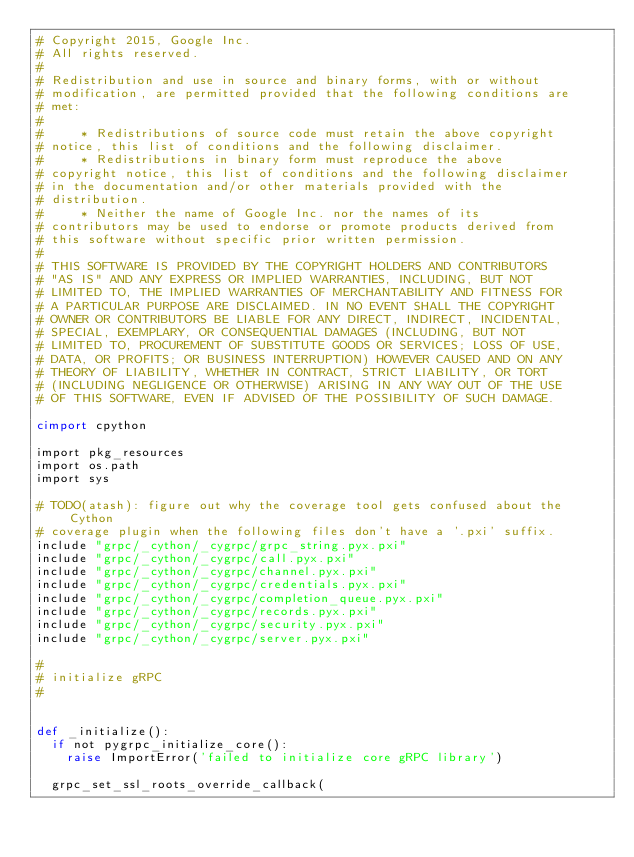Convert code to text. <code><loc_0><loc_0><loc_500><loc_500><_Cython_># Copyright 2015, Google Inc.
# All rights reserved.
#
# Redistribution and use in source and binary forms, with or without
# modification, are permitted provided that the following conditions are
# met:
#
#     * Redistributions of source code must retain the above copyright
# notice, this list of conditions and the following disclaimer.
#     * Redistributions in binary form must reproduce the above
# copyright notice, this list of conditions and the following disclaimer
# in the documentation and/or other materials provided with the
# distribution.
#     * Neither the name of Google Inc. nor the names of its
# contributors may be used to endorse or promote products derived from
# this software without specific prior written permission.
#
# THIS SOFTWARE IS PROVIDED BY THE COPYRIGHT HOLDERS AND CONTRIBUTORS
# "AS IS" AND ANY EXPRESS OR IMPLIED WARRANTIES, INCLUDING, BUT NOT
# LIMITED TO, THE IMPLIED WARRANTIES OF MERCHANTABILITY AND FITNESS FOR
# A PARTICULAR PURPOSE ARE DISCLAIMED. IN NO EVENT SHALL THE COPYRIGHT
# OWNER OR CONTRIBUTORS BE LIABLE FOR ANY DIRECT, INDIRECT, INCIDENTAL,
# SPECIAL, EXEMPLARY, OR CONSEQUENTIAL DAMAGES (INCLUDING, BUT NOT
# LIMITED TO, PROCUREMENT OF SUBSTITUTE GOODS OR SERVICES; LOSS OF USE,
# DATA, OR PROFITS; OR BUSINESS INTERRUPTION) HOWEVER CAUSED AND ON ANY
# THEORY OF LIABILITY, WHETHER IN CONTRACT, STRICT LIABILITY, OR TORT
# (INCLUDING NEGLIGENCE OR OTHERWISE) ARISING IN ANY WAY OUT OF THE USE
# OF THIS SOFTWARE, EVEN IF ADVISED OF THE POSSIBILITY OF SUCH DAMAGE.

cimport cpython

import pkg_resources
import os.path
import sys

# TODO(atash): figure out why the coverage tool gets confused about the Cython
# coverage plugin when the following files don't have a '.pxi' suffix.
include "grpc/_cython/_cygrpc/grpc_string.pyx.pxi"
include "grpc/_cython/_cygrpc/call.pyx.pxi"
include "grpc/_cython/_cygrpc/channel.pyx.pxi"
include "grpc/_cython/_cygrpc/credentials.pyx.pxi"
include "grpc/_cython/_cygrpc/completion_queue.pyx.pxi"
include "grpc/_cython/_cygrpc/records.pyx.pxi"
include "grpc/_cython/_cygrpc/security.pyx.pxi"
include "grpc/_cython/_cygrpc/server.pyx.pxi"

#
# initialize gRPC
#


def _initialize():
  if not pygrpc_initialize_core():
    raise ImportError('failed to initialize core gRPC library')

  grpc_set_ssl_roots_override_callback(</code> 